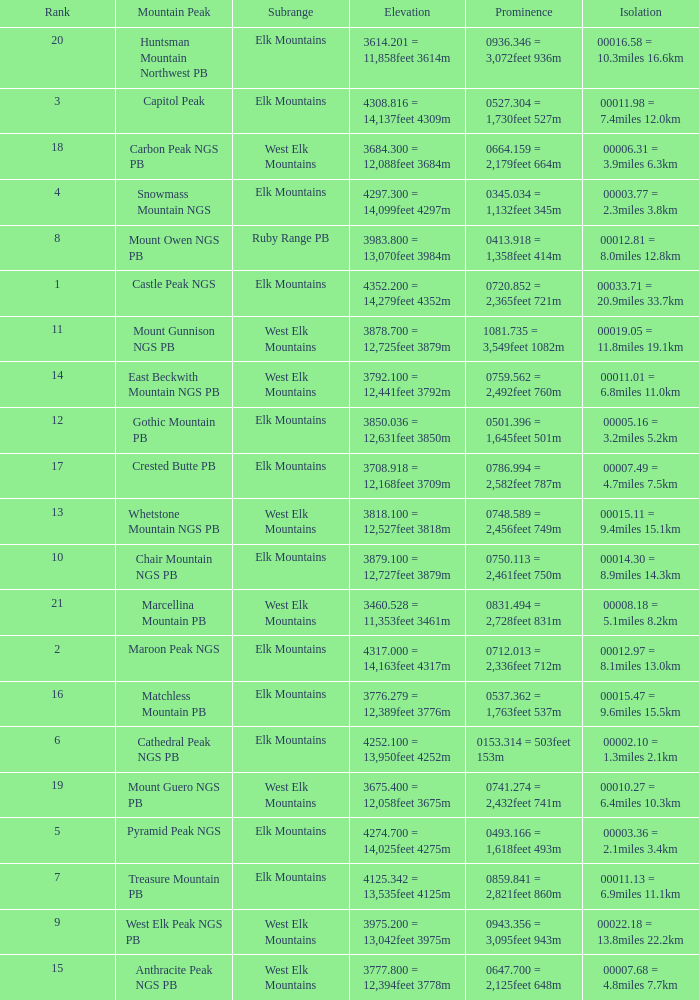Name the Rank of Rank Mountain Peak of crested butte pb? 17.0. 